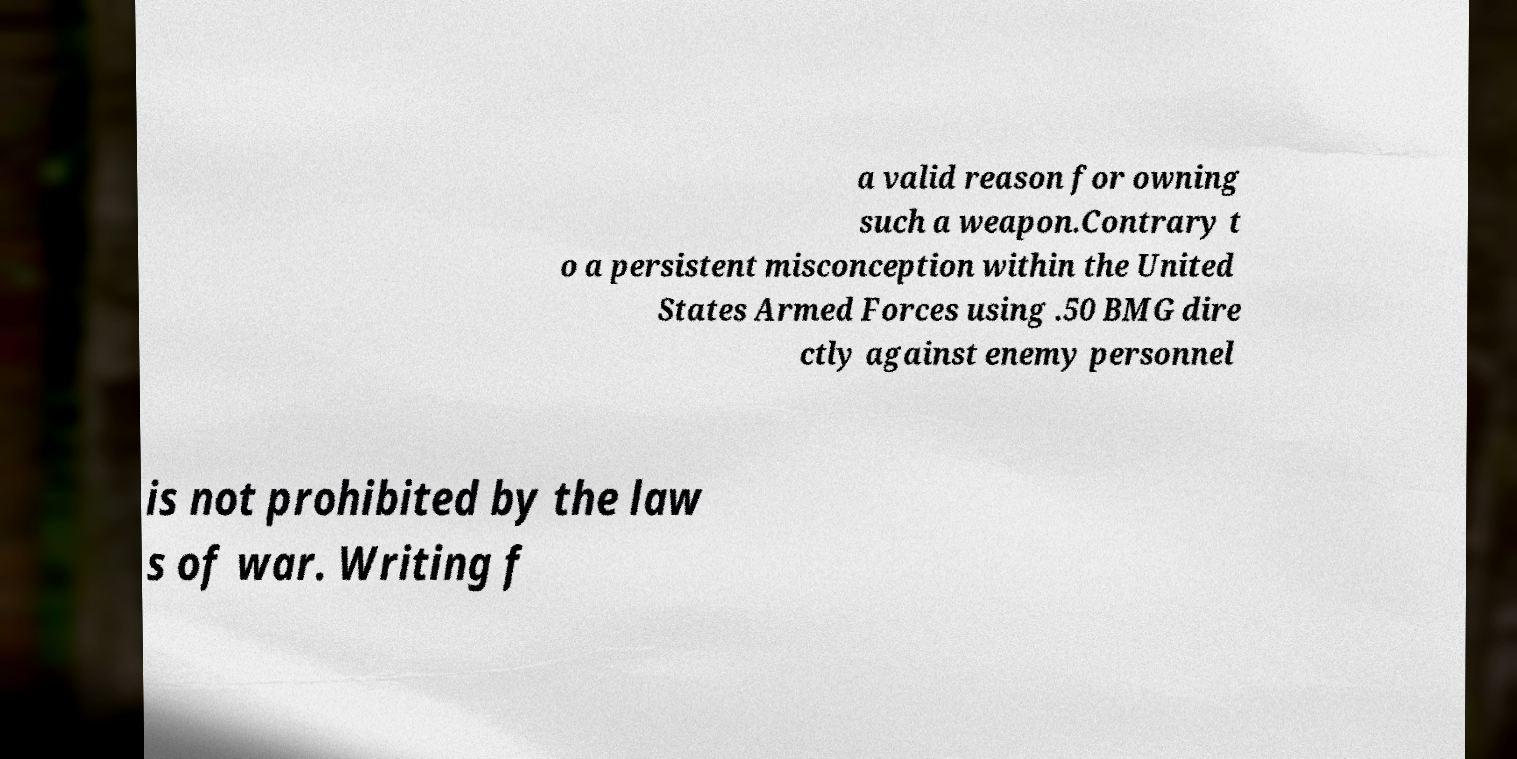For documentation purposes, I need the text within this image transcribed. Could you provide that? a valid reason for owning such a weapon.Contrary t o a persistent misconception within the United States Armed Forces using .50 BMG dire ctly against enemy personnel is not prohibited by the law s of war. Writing f 